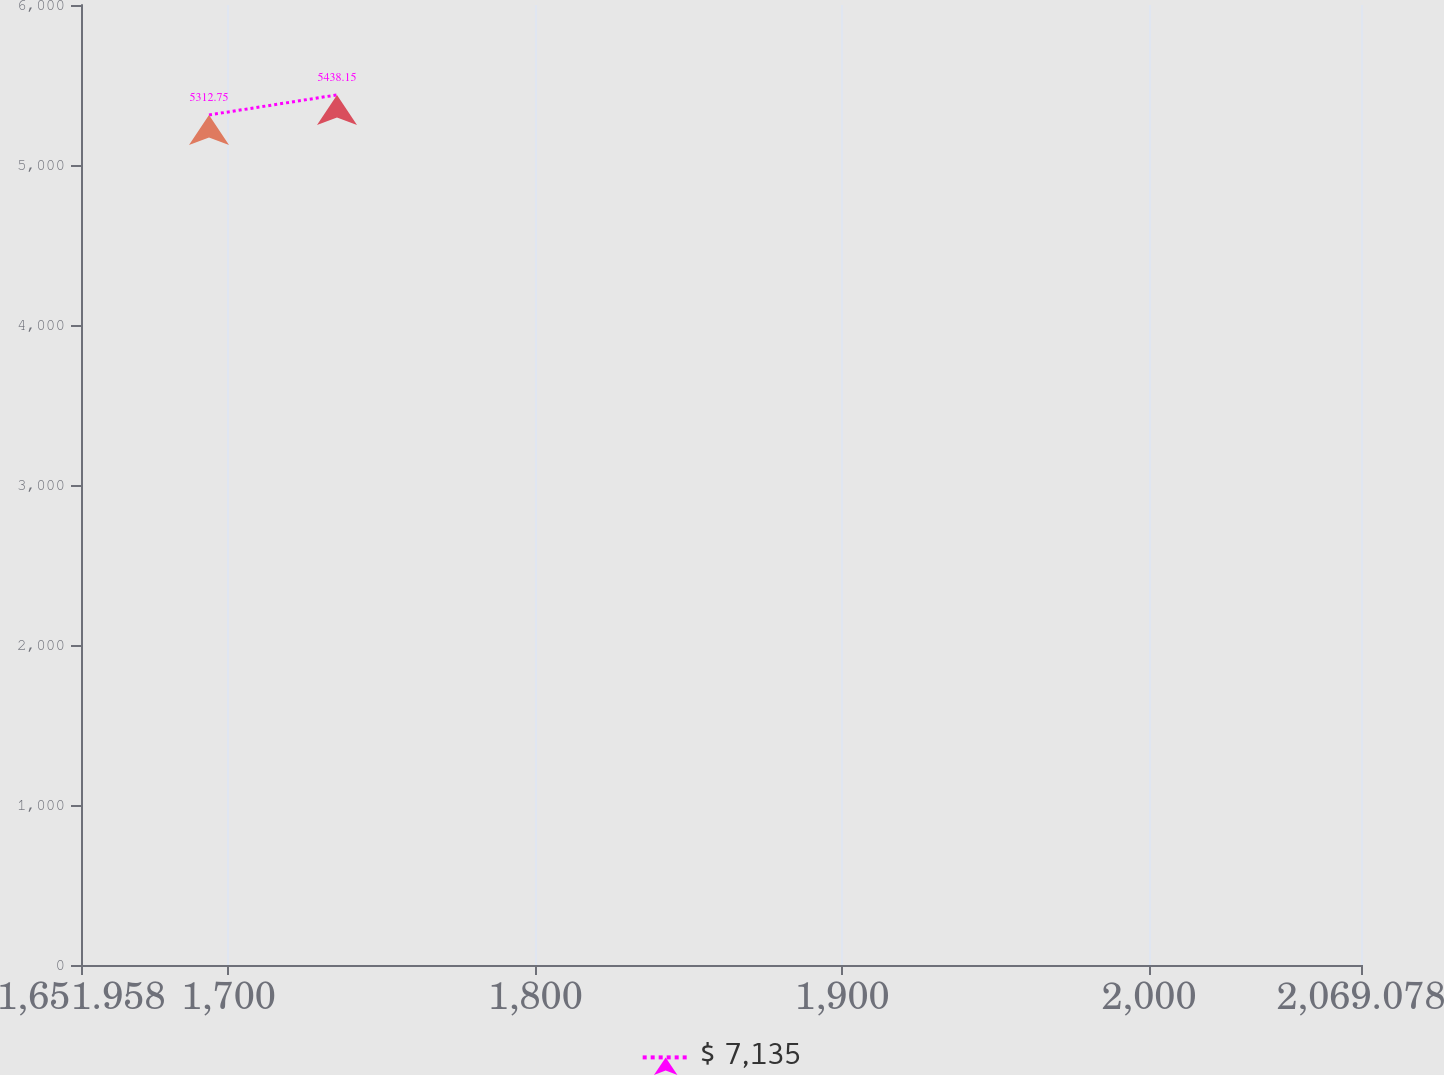Convert chart to OTSL. <chart><loc_0><loc_0><loc_500><loc_500><line_chart><ecel><fcel>$ 7,135<nl><fcel>1693.67<fcel>5312.75<nl><fcel>1735.38<fcel>5438.15<nl><fcel>2110.79<fcel>4753.45<nl></chart> 